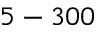<formula> <loc_0><loc_0><loc_500><loc_500>5 - 3 0 0</formula> 